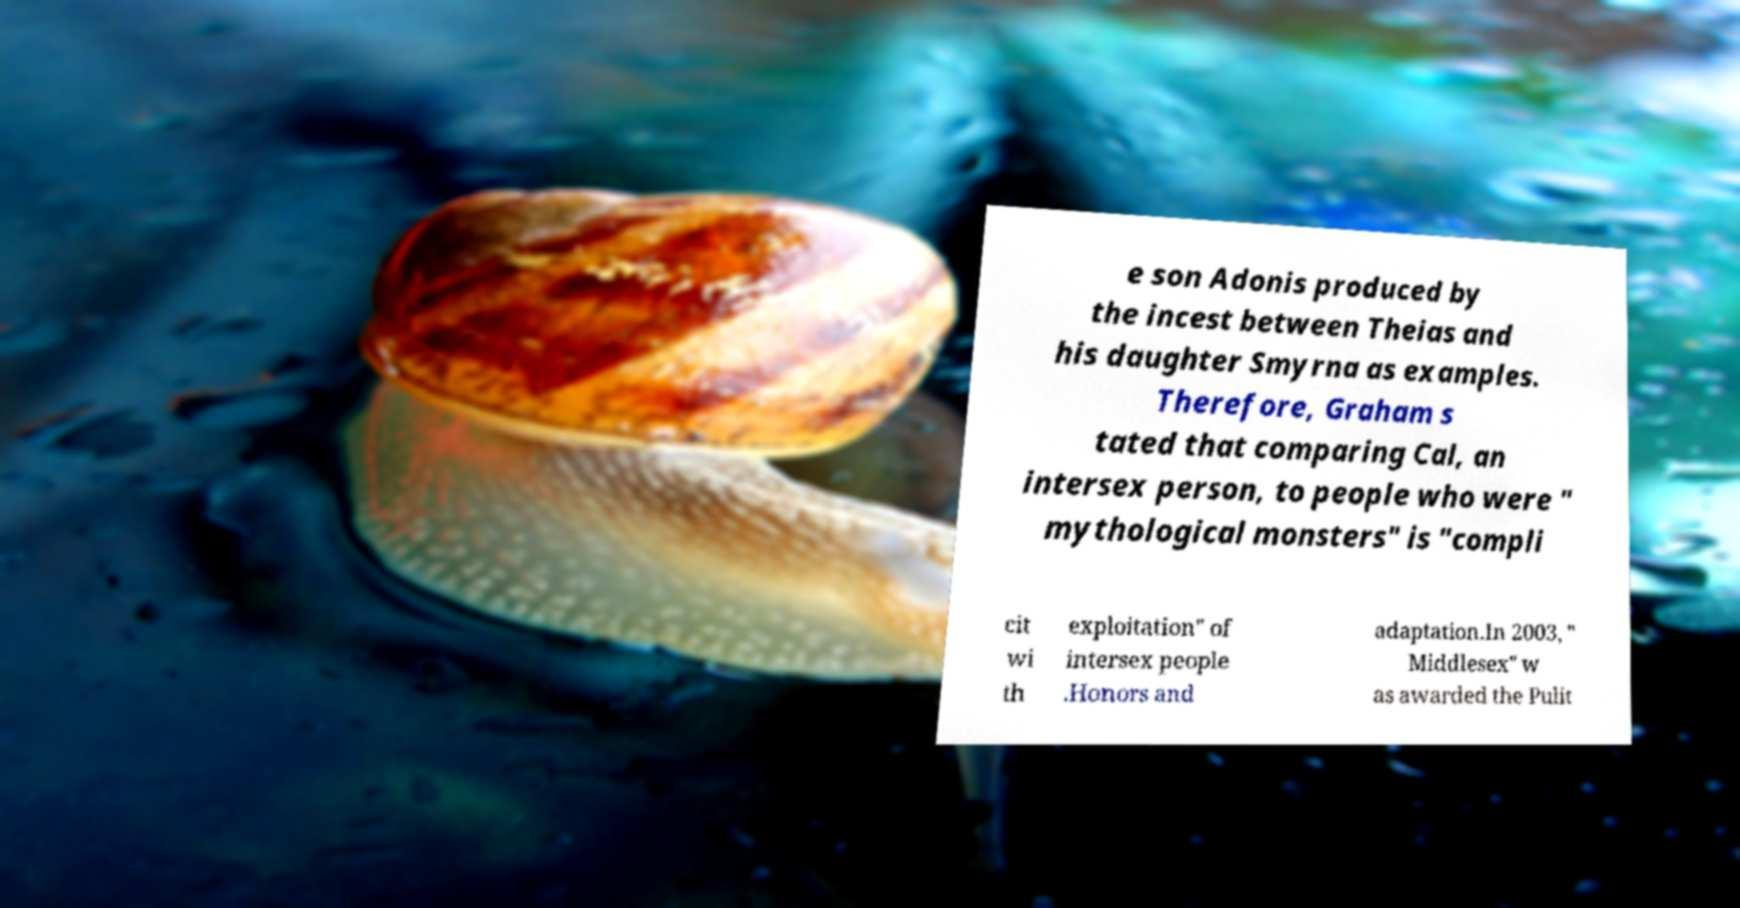Can you read and provide the text displayed in the image?This photo seems to have some interesting text. Can you extract and type it out for me? e son Adonis produced by the incest between Theias and his daughter Smyrna as examples. Therefore, Graham s tated that comparing Cal, an intersex person, to people who were " mythological monsters" is "compli cit wi th exploitation" of intersex people .Honors and adaptation.In 2003, " Middlesex" w as awarded the Pulit 